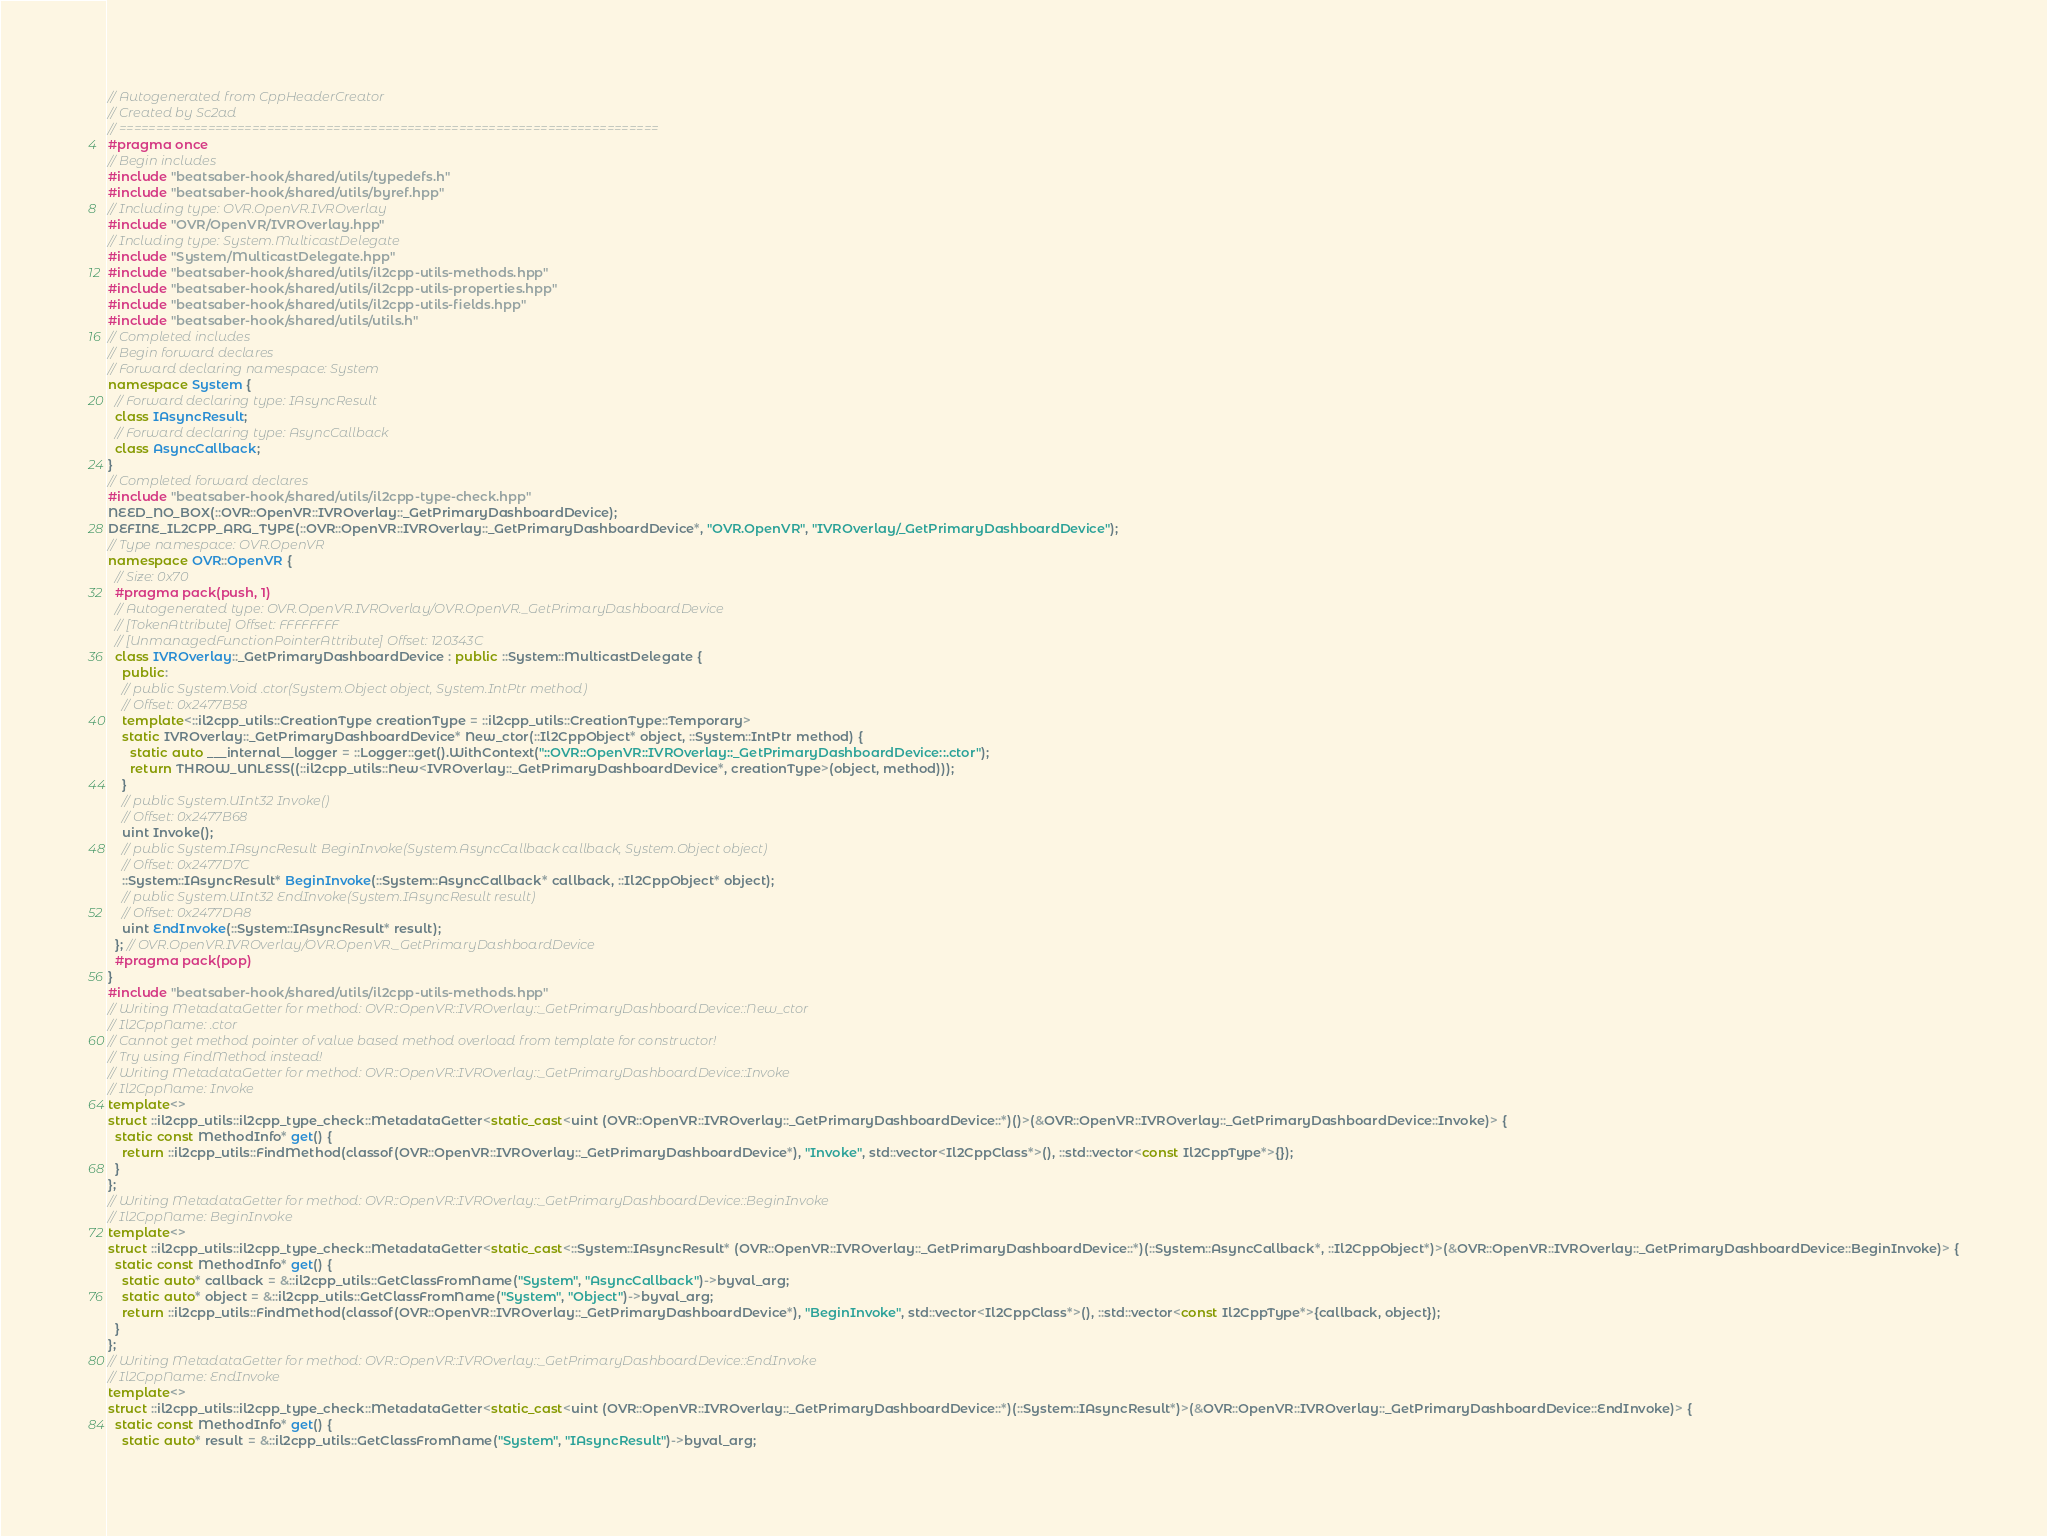Convert code to text. <code><loc_0><loc_0><loc_500><loc_500><_C++_>// Autogenerated from CppHeaderCreator
// Created by Sc2ad
// =========================================================================
#pragma once
// Begin includes
#include "beatsaber-hook/shared/utils/typedefs.h"
#include "beatsaber-hook/shared/utils/byref.hpp"
// Including type: OVR.OpenVR.IVROverlay
#include "OVR/OpenVR/IVROverlay.hpp"
// Including type: System.MulticastDelegate
#include "System/MulticastDelegate.hpp"
#include "beatsaber-hook/shared/utils/il2cpp-utils-methods.hpp"
#include "beatsaber-hook/shared/utils/il2cpp-utils-properties.hpp"
#include "beatsaber-hook/shared/utils/il2cpp-utils-fields.hpp"
#include "beatsaber-hook/shared/utils/utils.h"
// Completed includes
// Begin forward declares
// Forward declaring namespace: System
namespace System {
  // Forward declaring type: IAsyncResult
  class IAsyncResult;
  // Forward declaring type: AsyncCallback
  class AsyncCallback;
}
// Completed forward declares
#include "beatsaber-hook/shared/utils/il2cpp-type-check.hpp"
NEED_NO_BOX(::OVR::OpenVR::IVROverlay::_GetPrimaryDashboardDevice);
DEFINE_IL2CPP_ARG_TYPE(::OVR::OpenVR::IVROverlay::_GetPrimaryDashboardDevice*, "OVR.OpenVR", "IVROverlay/_GetPrimaryDashboardDevice");
// Type namespace: OVR.OpenVR
namespace OVR::OpenVR {
  // Size: 0x70
  #pragma pack(push, 1)
  // Autogenerated type: OVR.OpenVR.IVROverlay/OVR.OpenVR._GetPrimaryDashboardDevice
  // [TokenAttribute] Offset: FFFFFFFF
  // [UnmanagedFunctionPointerAttribute] Offset: 120343C
  class IVROverlay::_GetPrimaryDashboardDevice : public ::System::MulticastDelegate {
    public:
    // public System.Void .ctor(System.Object object, System.IntPtr method)
    // Offset: 0x2477B58
    template<::il2cpp_utils::CreationType creationType = ::il2cpp_utils::CreationType::Temporary>
    static IVROverlay::_GetPrimaryDashboardDevice* New_ctor(::Il2CppObject* object, ::System::IntPtr method) {
      static auto ___internal__logger = ::Logger::get().WithContext("::OVR::OpenVR::IVROverlay::_GetPrimaryDashboardDevice::.ctor");
      return THROW_UNLESS((::il2cpp_utils::New<IVROverlay::_GetPrimaryDashboardDevice*, creationType>(object, method)));
    }
    // public System.UInt32 Invoke()
    // Offset: 0x2477B68
    uint Invoke();
    // public System.IAsyncResult BeginInvoke(System.AsyncCallback callback, System.Object object)
    // Offset: 0x2477D7C
    ::System::IAsyncResult* BeginInvoke(::System::AsyncCallback* callback, ::Il2CppObject* object);
    // public System.UInt32 EndInvoke(System.IAsyncResult result)
    // Offset: 0x2477DA8
    uint EndInvoke(::System::IAsyncResult* result);
  }; // OVR.OpenVR.IVROverlay/OVR.OpenVR._GetPrimaryDashboardDevice
  #pragma pack(pop)
}
#include "beatsaber-hook/shared/utils/il2cpp-utils-methods.hpp"
// Writing MetadataGetter for method: OVR::OpenVR::IVROverlay::_GetPrimaryDashboardDevice::New_ctor
// Il2CppName: .ctor
// Cannot get method pointer of value based method overload from template for constructor!
// Try using FindMethod instead!
// Writing MetadataGetter for method: OVR::OpenVR::IVROverlay::_GetPrimaryDashboardDevice::Invoke
// Il2CppName: Invoke
template<>
struct ::il2cpp_utils::il2cpp_type_check::MetadataGetter<static_cast<uint (OVR::OpenVR::IVROverlay::_GetPrimaryDashboardDevice::*)()>(&OVR::OpenVR::IVROverlay::_GetPrimaryDashboardDevice::Invoke)> {
  static const MethodInfo* get() {
    return ::il2cpp_utils::FindMethod(classof(OVR::OpenVR::IVROverlay::_GetPrimaryDashboardDevice*), "Invoke", std::vector<Il2CppClass*>(), ::std::vector<const Il2CppType*>{});
  }
};
// Writing MetadataGetter for method: OVR::OpenVR::IVROverlay::_GetPrimaryDashboardDevice::BeginInvoke
// Il2CppName: BeginInvoke
template<>
struct ::il2cpp_utils::il2cpp_type_check::MetadataGetter<static_cast<::System::IAsyncResult* (OVR::OpenVR::IVROverlay::_GetPrimaryDashboardDevice::*)(::System::AsyncCallback*, ::Il2CppObject*)>(&OVR::OpenVR::IVROverlay::_GetPrimaryDashboardDevice::BeginInvoke)> {
  static const MethodInfo* get() {
    static auto* callback = &::il2cpp_utils::GetClassFromName("System", "AsyncCallback")->byval_arg;
    static auto* object = &::il2cpp_utils::GetClassFromName("System", "Object")->byval_arg;
    return ::il2cpp_utils::FindMethod(classof(OVR::OpenVR::IVROverlay::_GetPrimaryDashboardDevice*), "BeginInvoke", std::vector<Il2CppClass*>(), ::std::vector<const Il2CppType*>{callback, object});
  }
};
// Writing MetadataGetter for method: OVR::OpenVR::IVROverlay::_GetPrimaryDashboardDevice::EndInvoke
// Il2CppName: EndInvoke
template<>
struct ::il2cpp_utils::il2cpp_type_check::MetadataGetter<static_cast<uint (OVR::OpenVR::IVROverlay::_GetPrimaryDashboardDevice::*)(::System::IAsyncResult*)>(&OVR::OpenVR::IVROverlay::_GetPrimaryDashboardDevice::EndInvoke)> {
  static const MethodInfo* get() {
    static auto* result = &::il2cpp_utils::GetClassFromName("System", "IAsyncResult")->byval_arg;</code> 